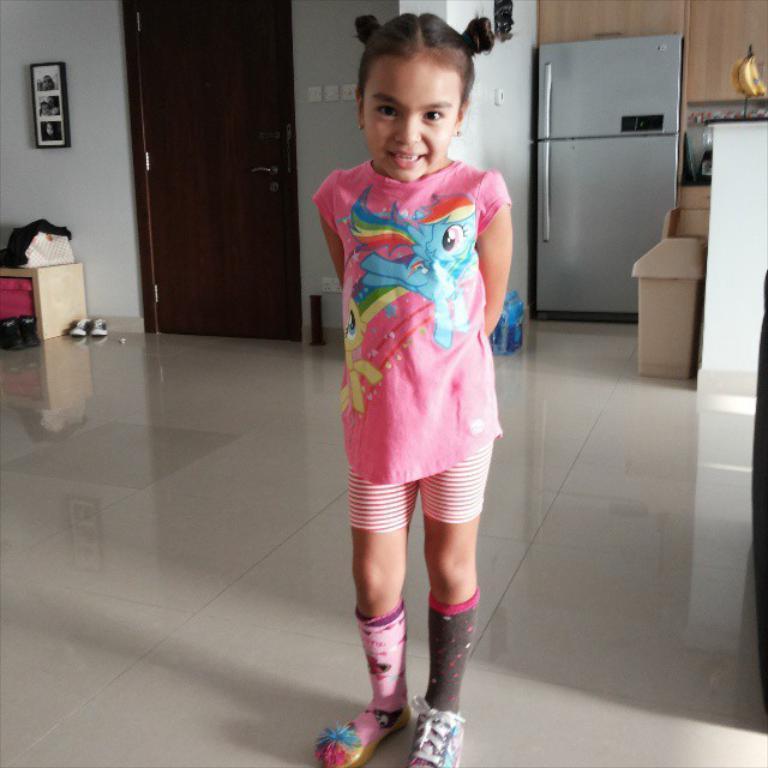Could you give a brief overview of what you see in this image? In this image I can see a girl standing and wearing pink dress. Back I can see a door,fridge,shoes and some objects on the floor. The frame is attached to the wall. 